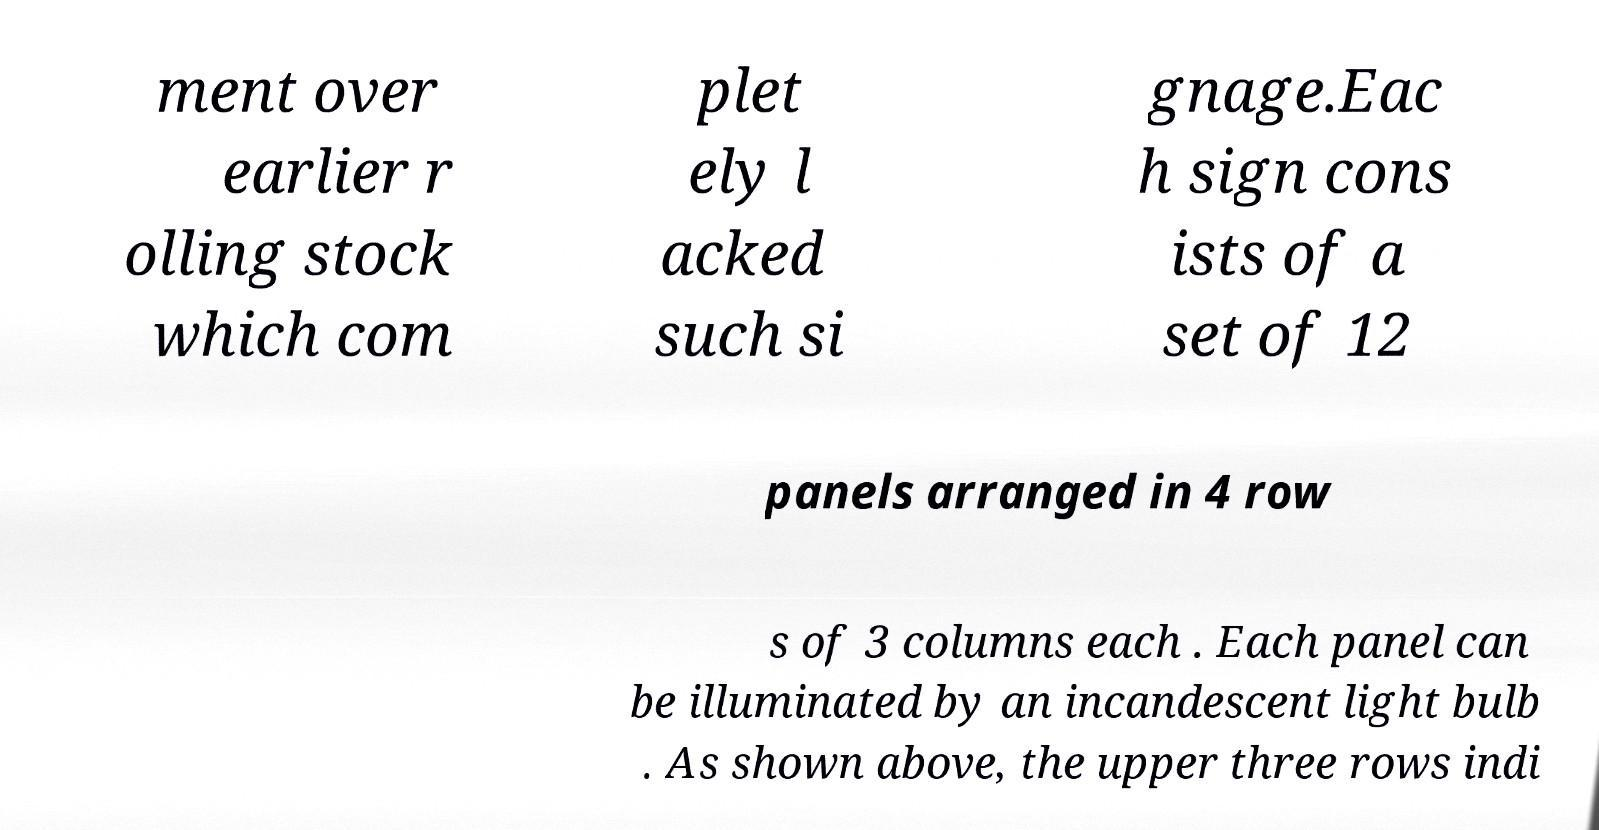Could you speculate on what era or context this signage system belongs to? Given the mention of 'earlier rolling stock' and 'incandescent light bulbs,' it suggests the signage could be from an earlier period, possibly the mid-20th century, when incandescent bulbs were common for lighting. It may relate to a railway or subway system where rolling stock typically refers to vehicles like trains or trams. 